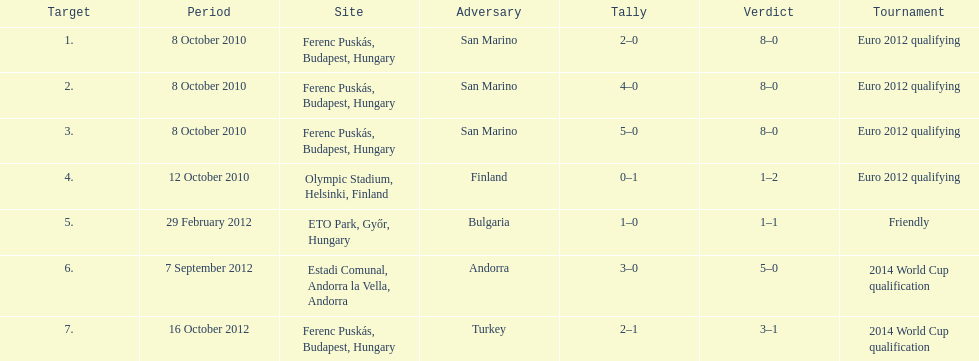Can you parse all the data within this table? {'header': ['Target', 'Period', 'Site', 'Adversary', 'Tally', 'Verdict', 'Tournament'], 'rows': [['1.', '8 October 2010', 'Ferenc Puskás, Budapest, Hungary', 'San Marino', '2–0', '8–0', 'Euro 2012 qualifying'], ['2.', '8 October 2010', 'Ferenc Puskás, Budapest, Hungary', 'San Marino', '4–0', '8–0', 'Euro 2012 qualifying'], ['3.', '8 October 2010', 'Ferenc Puskás, Budapest, Hungary', 'San Marino', '5–0', '8–0', 'Euro 2012 qualifying'], ['4.', '12 October 2010', 'Olympic Stadium, Helsinki, Finland', 'Finland', '0–1', '1–2', 'Euro 2012 qualifying'], ['5.', '29 February 2012', 'ETO Park, Győr, Hungary', 'Bulgaria', '1–0', '1–1', 'Friendly'], ['6.', '7 September 2012', 'Estadi Comunal, Andorra la Vella, Andorra', 'Andorra', '3–0', '5–0', '2014 World Cup qualification'], ['7.', '16 October 2012', 'Ferenc Puskás, Budapest, Hungary', 'Turkey', '2–1', '3–1', '2014 World Cup qualification']]} How many consecutive games were goals were against san marino? 3. 